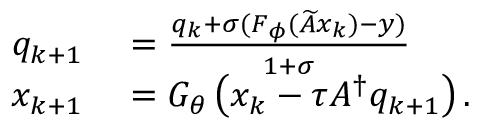Convert formula to latex. <formula><loc_0><loc_0><loc_500><loc_500>\begin{array} { r l } { q _ { k + 1 } } & = \frac { q _ { k } + \sigma ( F _ { \phi } ( \widetilde { A } x _ { k } ) - y ) } { 1 + \sigma } } \\ { x _ { k + 1 } } & = G _ { \theta } \left ( x _ { k } - \tau A ^ { \dagger } q _ { k + 1 } \right ) . } \end{array}</formula> 